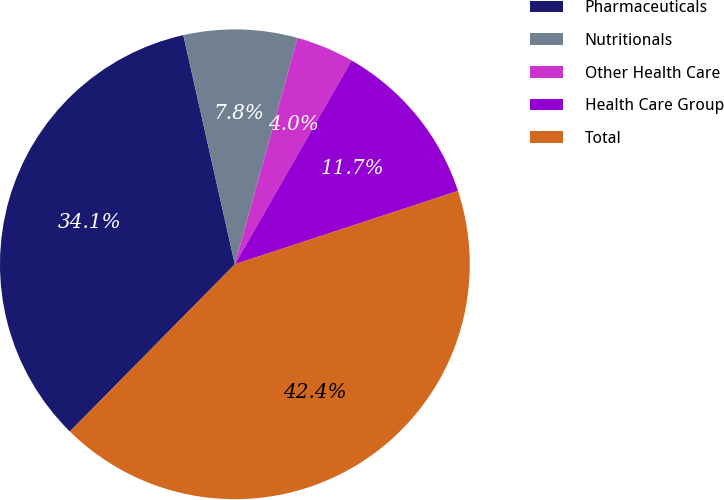Convert chart to OTSL. <chart><loc_0><loc_0><loc_500><loc_500><pie_chart><fcel>Pharmaceuticals<fcel>Nutritionals<fcel>Other Health Care<fcel>Health Care Group<fcel>Total<nl><fcel>34.09%<fcel>7.82%<fcel>3.98%<fcel>11.67%<fcel>42.45%<nl></chart> 